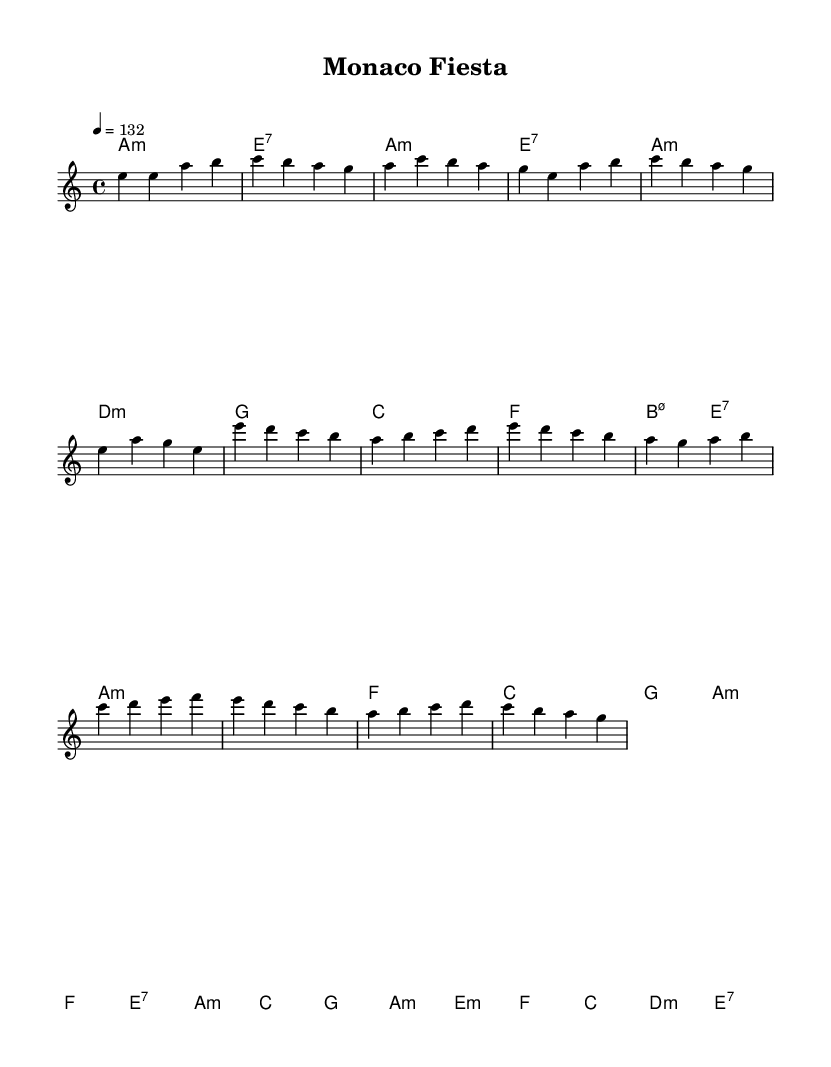What is the key signature of this music? The key signature is A minor, which has no sharps or flats.
Answer: A minor What is the time signature of the piece? The time signature is indicated by the notation at the beginning, which shows that there are four beats per measure and the quarter note gets the beat.
Answer: 4/4 What is the tempo marking for the piece? The tempo marking indicates that the piece should be played at a speed of 132 beats per minute, as shown by the numerical indication in the code.
Answer: 132 How many measures are in the verse section? The verse section consists of four measures, each containing a different sequence of notes, which can be counted from the notation provided.
Answer: 4 What musical form is primarily used in this piece? The piece utilizes a common form of verse-chorus structure, which alternates between different sections like verses and choruses, indicative of many fusion styles.
Answer: Verse-Chorus What chords are used in the chorus section? The chorus section is composed of six chords: A minor, F, C, G, A minor, F, E7, A minor, which can be identified by looking at the chord notation in the score.
Answer: A minor, F, C, G, A minor, F, E7, A minor Which section contains a bridge? The bridge is a specific transitional section that can typically be found after the verse and before returning to the chorus; in this case, it's clearly demarked in the melody and harmonies.
Answer: Bridge 